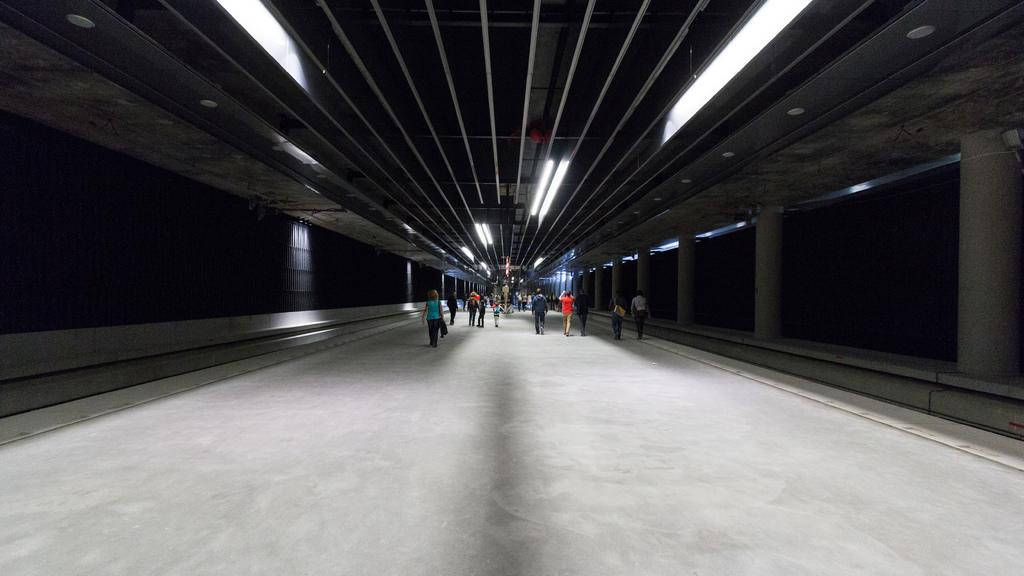What is happening with the group of people in the image? The people are walking in the image. Can you describe the clothing of the person in front? The person in front is wearing a blue shirt and black pants. What can be seen on the left side of the image? There is a black wall on the left side of the image. What is on the right side of the image? There is a gray wall on the right side of the image. What type of bell can be heard ringing in the image? There is no bell present in the image, and therefore no sound can be heard. Can you describe the curve of the basketball in the image? There is no basketball present in the image, so we cannot describe its curve. 